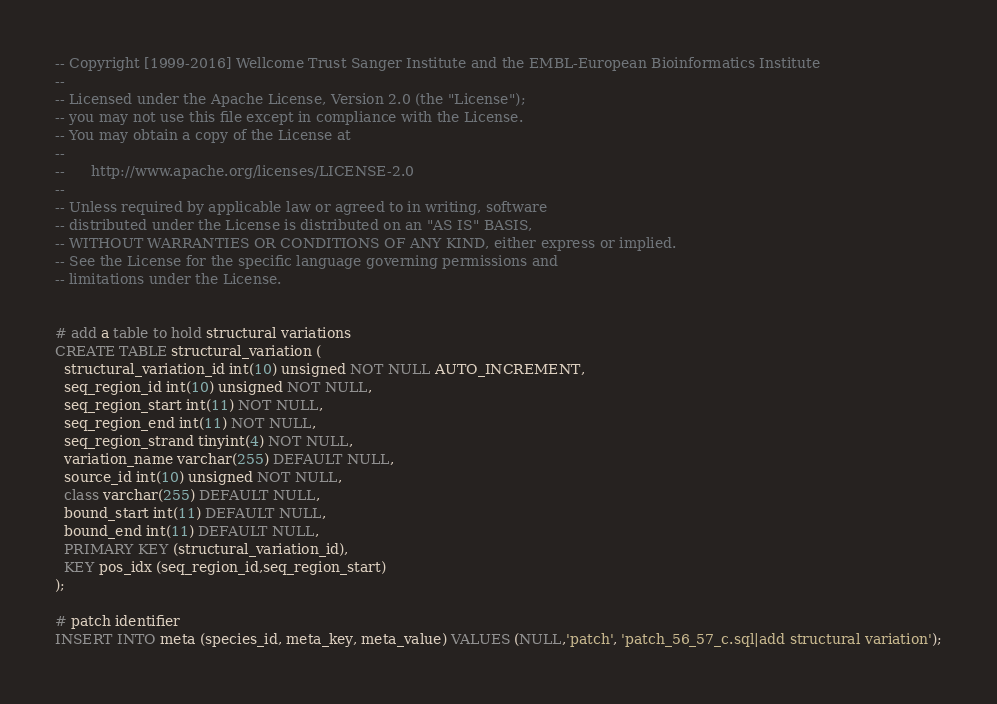<code> <loc_0><loc_0><loc_500><loc_500><_SQL_>-- Copyright [1999-2016] Wellcome Trust Sanger Institute and the EMBL-European Bioinformatics Institute
-- 
-- Licensed under the Apache License, Version 2.0 (the "License");
-- you may not use this file except in compliance with the License.
-- You may obtain a copy of the License at
-- 
--      http://www.apache.org/licenses/LICENSE-2.0
-- 
-- Unless required by applicable law or agreed to in writing, software
-- distributed under the License is distributed on an "AS IS" BASIS,
-- WITHOUT WARRANTIES OR CONDITIONS OF ANY KIND, either express or implied.
-- See the License for the specific language governing permissions and
-- limitations under the License.


# add a table to hold structural variations
CREATE TABLE structural_variation (
  structural_variation_id int(10) unsigned NOT NULL AUTO_INCREMENT,
  seq_region_id int(10) unsigned NOT NULL,
  seq_region_start int(11) NOT NULL,
  seq_region_end int(11) NOT NULL,
  seq_region_strand tinyint(4) NOT NULL,
  variation_name varchar(255) DEFAULT NULL,
  source_id int(10) unsigned NOT NULL,
  class varchar(255) DEFAULT NULL,
  bound_start int(11) DEFAULT NULL,
  bound_end int(11) DEFAULT NULL,
  PRIMARY KEY (structural_variation_id),
  KEY pos_idx (seq_region_id,seq_region_start)
);

# patch identifier
INSERT INTO meta (species_id, meta_key, meta_value) VALUES (NULL,'patch', 'patch_56_57_c.sql|add structural variation');
</code> 